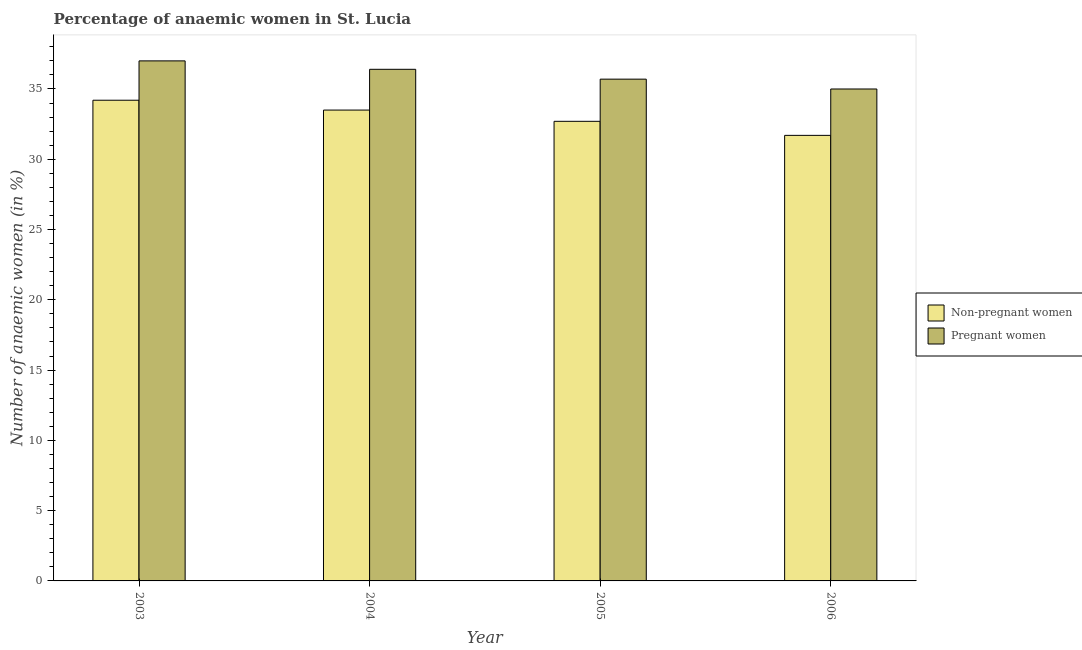How many different coloured bars are there?
Provide a succinct answer. 2. Are the number of bars on each tick of the X-axis equal?
Offer a very short reply. Yes. How many bars are there on the 4th tick from the right?
Your answer should be very brief. 2. What is the label of the 3rd group of bars from the left?
Provide a short and direct response. 2005. In how many cases, is the number of bars for a given year not equal to the number of legend labels?
Your response must be concise. 0. What is the percentage of non-pregnant anaemic women in 2003?
Keep it short and to the point. 34.2. In which year was the percentage of non-pregnant anaemic women maximum?
Provide a succinct answer. 2003. What is the total percentage of non-pregnant anaemic women in the graph?
Provide a succinct answer. 132.1. What is the difference between the percentage of non-pregnant anaemic women in 2004 and that in 2006?
Make the answer very short. 1.8. What is the difference between the percentage of non-pregnant anaemic women in 2003 and the percentage of pregnant anaemic women in 2004?
Make the answer very short. 0.7. What is the average percentage of pregnant anaemic women per year?
Your answer should be compact. 36.03. In the year 2005, what is the difference between the percentage of pregnant anaemic women and percentage of non-pregnant anaemic women?
Offer a very short reply. 0. In how many years, is the percentage of non-pregnant anaemic women greater than 19 %?
Provide a short and direct response. 4. What is the ratio of the percentage of non-pregnant anaemic women in 2003 to that in 2005?
Offer a very short reply. 1.05. Is the percentage of pregnant anaemic women in 2003 less than that in 2004?
Ensure brevity in your answer.  No. Is the difference between the percentage of non-pregnant anaemic women in 2004 and 2005 greater than the difference between the percentage of pregnant anaemic women in 2004 and 2005?
Your answer should be very brief. No. What is the difference between the highest and the second highest percentage of non-pregnant anaemic women?
Make the answer very short. 0.7. In how many years, is the percentage of pregnant anaemic women greater than the average percentage of pregnant anaemic women taken over all years?
Provide a short and direct response. 2. What does the 2nd bar from the left in 2003 represents?
Keep it short and to the point. Pregnant women. What does the 1st bar from the right in 2005 represents?
Make the answer very short. Pregnant women. How many years are there in the graph?
Provide a short and direct response. 4. Are the values on the major ticks of Y-axis written in scientific E-notation?
Your answer should be very brief. No. How many legend labels are there?
Your answer should be very brief. 2. How are the legend labels stacked?
Provide a succinct answer. Vertical. What is the title of the graph?
Offer a very short reply. Percentage of anaemic women in St. Lucia. Does "Net savings(excluding particulate emission damage)" appear as one of the legend labels in the graph?
Offer a terse response. No. What is the label or title of the Y-axis?
Your answer should be very brief. Number of anaemic women (in %). What is the Number of anaemic women (in %) in Non-pregnant women in 2003?
Make the answer very short. 34.2. What is the Number of anaemic women (in %) of Non-pregnant women in 2004?
Give a very brief answer. 33.5. What is the Number of anaemic women (in %) of Pregnant women in 2004?
Your response must be concise. 36.4. What is the Number of anaemic women (in %) of Non-pregnant women in 2005?
Offer a terse response. 32.7. What is the Number of anaemic women (in %) of Pregnant women in 2005?
Your response must be concise. 35.7. What is the Number of anaemic women (in %) in Non-pregnant women in 2006?
Make the answer very short. 31.7. What is the Number of anaemic women (in %) of Pregnant women in 2006?
Give a very brief answer. 35. Across all years, what is the maximum Number of anaemic women (in %) in Non-pregnant women?
Provide a short and direct response. 34.2. Across all years, what is the minimum Number of anaemic women (in %) in Non-pregnant women?
Make the answer very short. 31.7. Across all years, what is the minimum Number of anaemic women (in %) in Pregnant women?
Make the answer very short. 35. What is the total Number of anaemic women (in %) of Non-pregnant women in the graph?
Make the answer very short. 132.1. What is the total Number of anaemic women (in %) of Pregnant women in the graph?
Ensure brevity in your answer.  144.1. What is the difference between the Number of anaemic women (in %) in Pregnant women in 2003 and that in 2004?
Ensure brevity in your answer.  0.6. What is the difference between the Number of anaemic women (in %) of Non-pregnant women in 2003 and that in 2005?
Offer a terse response. 1.5. What is the difference between the Number of anaemic women (in %) in Non-pregnant women in 2003 and that in 2006?
Offer a very short reply. 2.5. What is the difference between the Number of anaemic women (in %) in Pregnant women in 2004 and that in 2005?
Provide a succinct answer. 0.7. What is the difference between the Number of anaemic women (in %) in Non-pregnant women in 2004 and that in 2006?
Provide a succinct answer. 1.8. What is the difference between the Number of anaemic women (in %) of Non-pregnant women in 2003 and the Number of anaemic women (in %) of Pregnant women in 2005?
Your answer should be compact. -1.5. What is the difference between the Number of anaemic women (in %) of Non-pregnant women in 2004 and the Number of anaemic women (in %) of Pregnant women in 2005?
Your answer should be compact. -2.2. What is the difference between the Number of anaemic women (in %) of Non-pregnant women in 2005 and the Number of anaemic women (in %) of Pregnant women in 2006?
Keep it short and to the point. -2.3. What is the average Number of anaemic women (in %) of Non-pregnant women per year?
Keep it short and to the point. 33.02. What is the average Number of anaemic women (in %) of Pregnant women per year?
Offer a terse response. 36.02. In the year 2003, what is the difference between the Number of anaemic women (in %) in Non-pregnant women and Number of anaemic women (in %) in Pregnant women?
Provide a short and direct response. -2.8. In the year 2004, what is the difference between the Number of anaemic women (in %) of Non-pregnant women and Number of anaemic women (in %) of Pregnant women?
Provide a short and direct response. -2.9. In the year 2005, what is the difference between the Number of anaemic women (in %) of Non-pregnant women and Number of anaemic women (in %) of Pregnant women?
Provide a short and direct response. -3. In the year 2006, what is the difference between the Number of anaemic women (in %) in Non-pregnant women and Number of anaemic women (in %) in Pregnant women?
Your answer should be compact. -3.3. What is the ratio of the Number of anaemic women (in %) of Non-pregnant women in 2003 to that in 2004?
Your answer should be very brief. 1.02. What is the ratio of the Number of anaemic women (in %) in Pregnant women in 2003 to that in 2004?
Your answer should be compact. 1.02. What is the ratio of the Number of anaemic women (in %) of Non-pregnant women in 2003 to that in 2005?
Your answer should be compact. 1.05. What is the ratio of the Number of anaemic women (in %) of Pregnant women in 2003 to that in 2005?
Your response must be concise. 1.04. What is the ratio of the Number of anaemic women (in %) of Non-pregnant women in 2003 to that in 2006?
Your answer should be very brief. 1.08. What is the ratio of the Number of anaemic women (in %) of Pregnant women in 2003 to that in 2006?
Make the answer very short. 1.06. What is the ratio of the Number of anaemic women (in %) in Non-pregnant women in 2004 to that in 2005?
Offer a very short reply. 1.02. What is the ratio of the Number of anaemic women (in %) of Pregnant women in 2004 to that in 2005?
Your answer should be compact. 1.02. What is the ratio of the Number of anaemic women (in %) in Non-pregnant women in 2004 to that in 2006?
Offer a terse response. 1.06. What is the ratio of the Number of anaemic women (in %) of Pregnant women in 2004 to that in 2006?
Ensure brevity in your answer.  1.04. What is the ratio of the Number of anaemic women (in %) in Non-pregnant women in 2005 to that in 2006?
Offer a terse response. 1.03. What is the difference between the highest and the second highest Number of anaemic women (in %) of Pregnant women?
Your answer should be compact. 0.6. What is the difference between the highest and the lowest Number of anaemic women (in %) in Non-pregnant women?
Your answer should be very brief. 2.5. What is the difference between the highest and the lowest Number of anaemic women (in %) of Pregnant women?
Give a very brief answer. 2. 